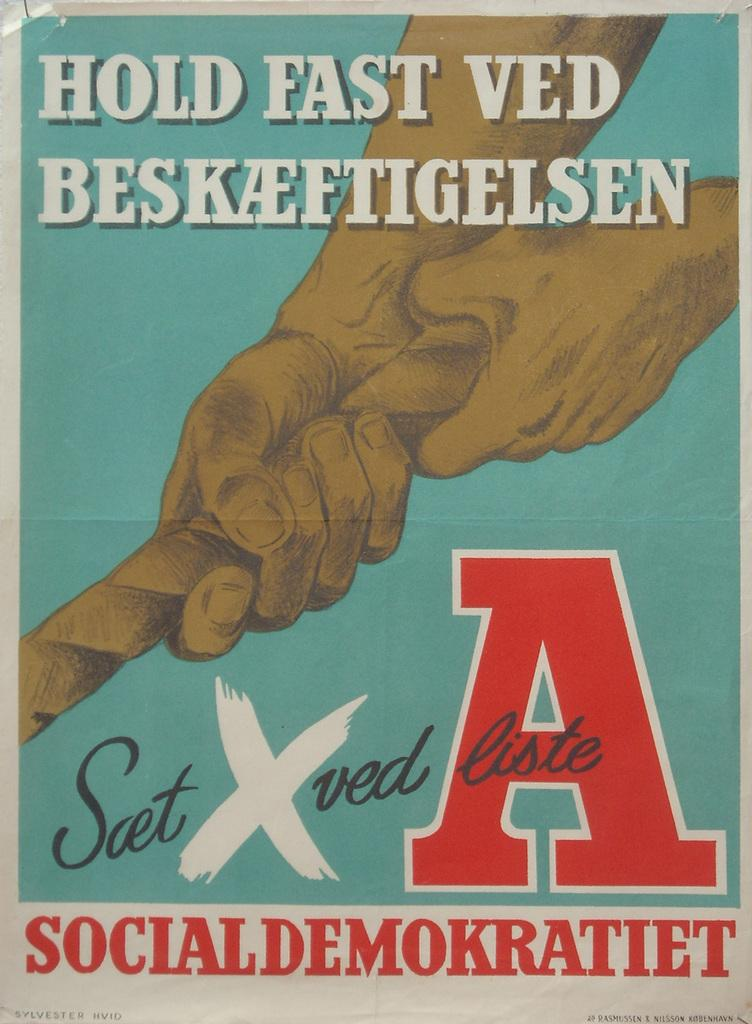<image>
Describe the image concisely. Hold Fast Ved Beskaeftigelsen with a hand and a rope on cover 